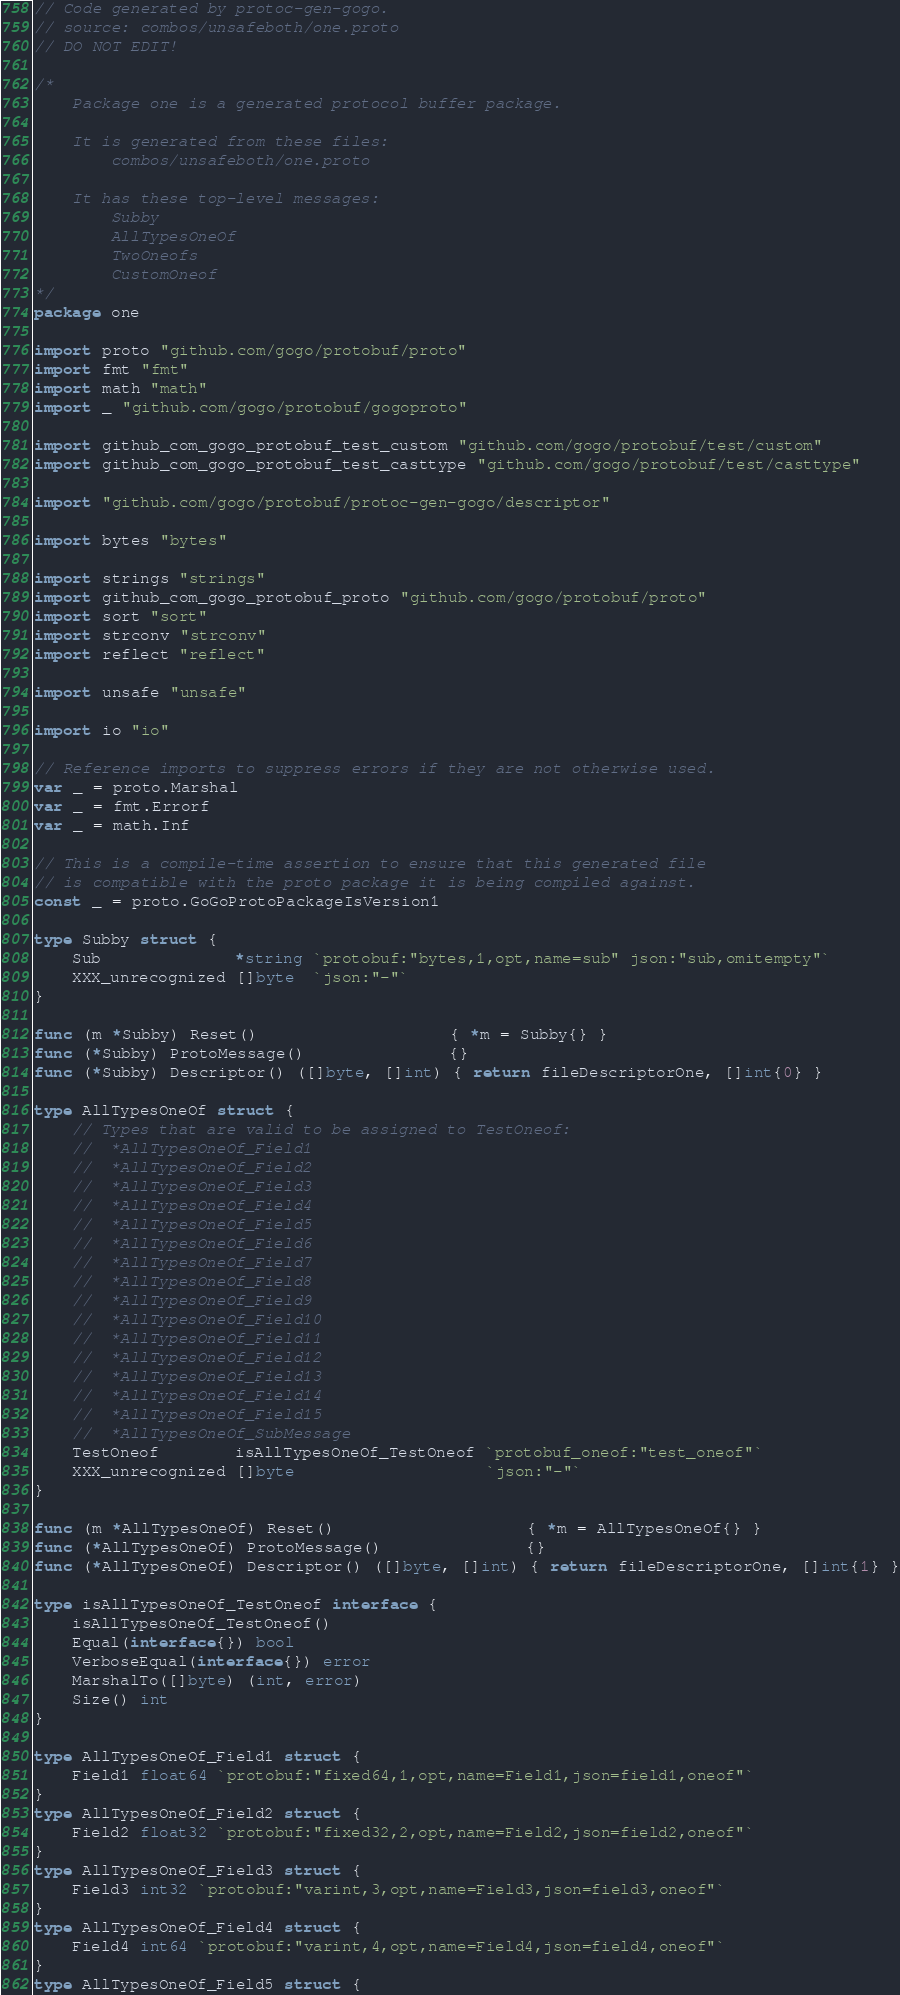Convert code to text. <code><loc_0><loc_0><loc_500><loc_500><_Go_>// Code generated by protoc-gen-gogo.
// source: combos/unsafeboth/one.proto
// DO NOT EDIT!

/*
	Package one is a generated protocol buffer package.

	It is generated from these files:
		combos/unsafeboth/one.proto

	It has these top-level messages:
		Subby
		AllTypesOneOf
		TwoOneofs
		CustomOneof
*/
package one

import proto "github.com/gogo/protobuf/proto"
import fmt "fmt"
import math "math"
import _ "github.com/gogo/protobuf/gogoproto"

import github_com_gogo_protobuf_test_custom "github.com/gogo/protobuf/test/custom"
import github_com_gogo_protobuf_test_casttype "github.com/gogo/protobuf/test/casttype"

import "github.com/gogo/protobuf/protoc-gen-gogo/descriptor"

import bytes "bytes"

import strings "strings"
import github_com_gogo_protobuf_proto "github.com/gogo/protobuf/proto"
import sort "sort"
import strconv "strconv"
import reflect "reflect"

import unsafe "unsafe"

import io "io"

// Reference imports to suppress errors if they are not otherwise used.
var _ = proto.Marshal
var _ = fmt.Errorf
var _ = math.Inf

// This is a compile-time assertion to ensure that this generated file
// is compatible with the proto package it is being compiled against.
const _ = proto.GoGoProtoPackageIsVersion1

type Subby struct {
	Sub              *string `protobuf:"bytes,1,opt,name=sub" json:"sub,omitempty"`
	XXX_unrecognized []byte  `json:"-"`
}

func (m *Subby) Reset()                    { *m = Subby{} }
func (*Subby) ProtoMessage()               {}
func (*Subby) Descriptor() ([]byte, []int) { return fileDescriptorOne, []int{0} }

type AllTypesOneOf struct {
	// Types that are valid to be assigned to TestOneof:
	//	*AllTypesOneOf_Field1
	//	*AllTypesOneOf_Field2
	//	*AllTypesOneOf_Field3
	//	*AllTypesOneOf_Field4
	//	*AllTypesOneOf_Field5
	//	*AllTypesOneOf_Field6
	//	*AllTypesOneOf_Field7
	//	*AllTypesOneOf_Field8
	//	*AllTypesOneOf_Field9
	//	*AllTypesOneOf_Field10
	//	*AllTypesOneOf_Field11
	//	*AllTypesOneOf_Field12
	//	*AllTypesOneOf_Field13
	//	*AllTypesOneOf_Field14
	//	*AllTypesOneOf_Field15
	//	*AllTypesOneOf_SubMessage
	TestOneof        isAllTypesOneOf_TestOneof `protobuf_oneof:"test_oneof"`
	XXX_unrecognized []byte                    `json:"-"`
}

func (m *AllTypesOneOf) Reset()                    { *m = AllTypesOneOf{} }
func (*AllTypesOneOf) ProtoMessage()               {}
func (*AllTypesOneOf) Descriptor() ([]byte, []int) { return fileDescriptorOne, []int{1} }

type isAllTypesOneOf_TestOneof interface {
	isAllTypesOneOf_TestOneof()
	Equal(interface{}) bool
	VerboseEqual(interface{}) error
	MarshalTo([]byte) (int, error)
	Size() int
}

type AllTypesOneOf_Field1 struct {
	Field1 float64 `protobuf:"fixed64,1,opt,name=Field1,json=field1,oneof"`
}
type AllTypesOneOf_Field2 struct {
	Field2 float32 `protobuf:"fixed32,2,opt,name=Field2,json=field2,oneof"`
}
type AllTypesOneOf_Field3 struct {
	Field3 int32 `protobuf:"varint,3,opt,name=Field3,json=field3,oneof"`
}
type AllTypesOneOf_Field4 struct {
	Field4 int64 `protobuf:"varint,4,opt,name=Field4,json=field4,oneof"`
}
type AllTypesOneOf_Field5 struct {</code> 